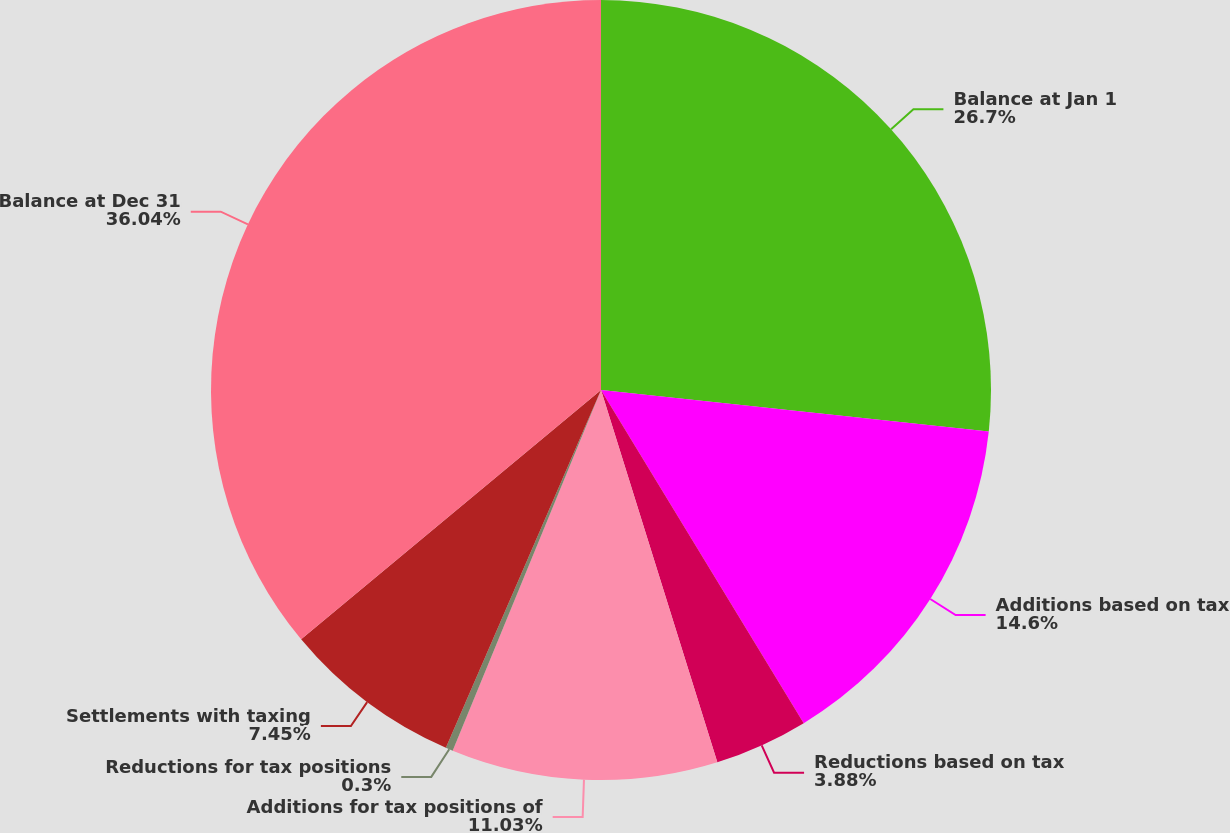Convert chart. <chart><loc_0><loc_0><loc_500><loc_500><pie_chart><fcel>Balance at Jan 1<fcel>Additions based on tax<fcel>Reductions based on tax<fcel>Additions for tax positions of<fcel>Reductions for tax positions<fcel>Settlements with taxing<fcel>Balance at Dec 31<nl><fcel>26.7%<fcel>14.6%<fcel>3.88%<fcel>11.03%<fcel>0.3%<fcel>7.45%<fcel>36.04%<nl></chart> 